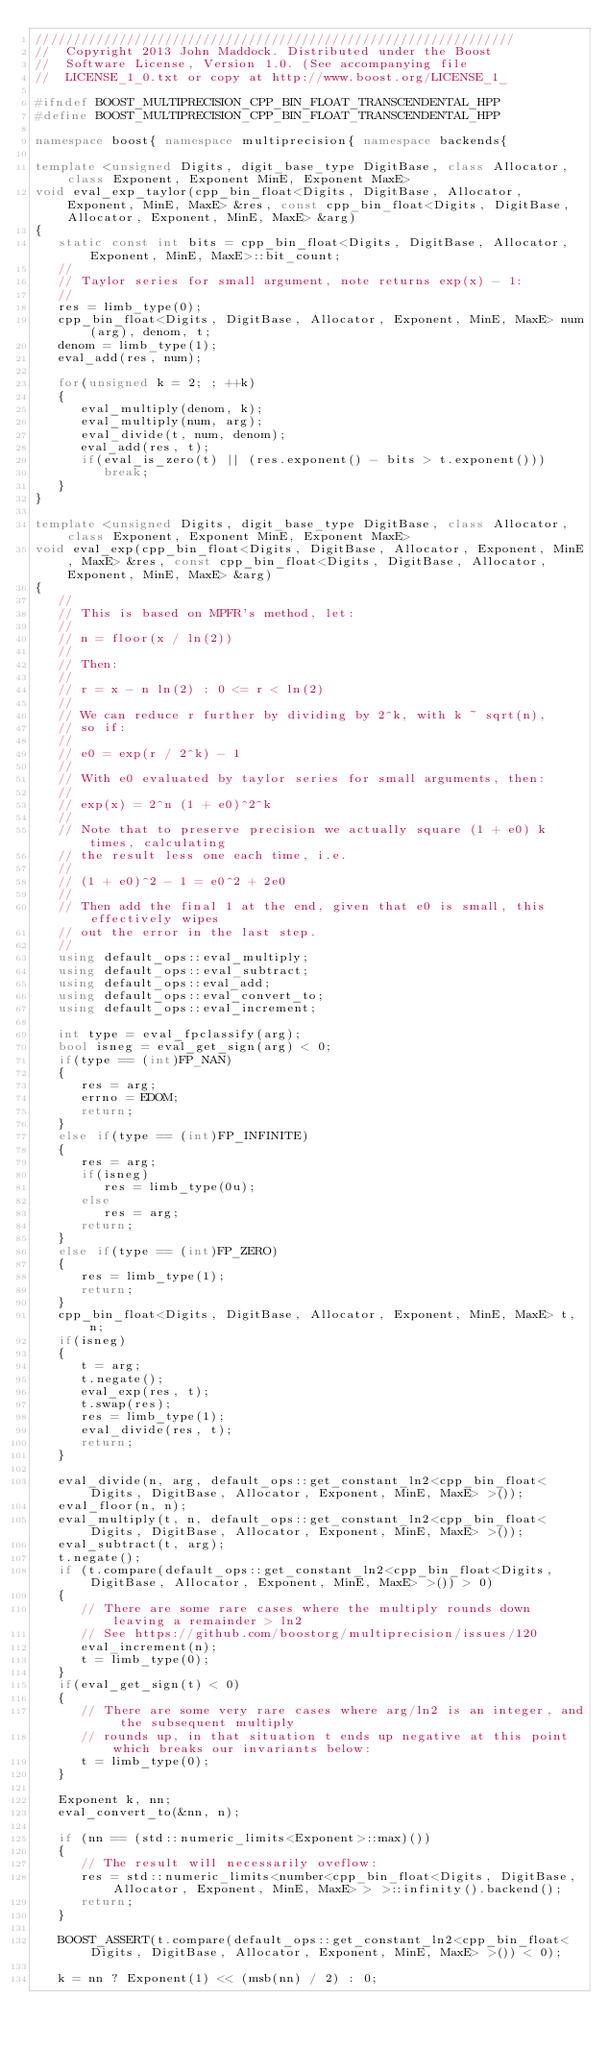<code> <loc_0><loc_0><loc_500><loc_500><_C++_>///////////////////////////////////////////////////////////////
//  Copyright 2013 John Maddock. Distributed under the Boost
//  Software License, Version 1.0. (See accompanying file
//  LICENSE_1_0.txt or copy at http://www.boost.org/LICENSE_1_

#ifndef BOOST_MULTIPRECISION_CPP_BIN_FLOAT_TRANSCENDENTAL_HPP
#define BOOST_MULTIPRECISION_CPP_BIN_FLOAT_TRANSCENDENTAL_HPP

namespace boost{ namespace multiprecision{ namespace backends{

template <unsigned Digits, digit_base_type DigitBase, class Allocator, class Exponent, Exponent MinE, Exponent MaxE>
void eval_exp_taylor(cpp_bin_float<Digits, DigitBase, Allocator, Exponent, MinE, MaxE> &res, const cpp_bin_float<Digits, DigitBase, Allocator, Exponent, MinE, MaxE> &arg)
{
   static const int bits = cpp_bin_float<Digits, DigitBase, Allocator, Exponent, MinE, MaxE>::bit_count;
   //
   // Taylor series for small argument, note returns exp(x) - 1:
   //
   res = limb_type(0);
   cpp_bin_float<Digits, DigitBase, Allocator, Exponent, MinE, MaxE> num(arg), denom, t;
   denom = limb_type(1);
   eval_add(res, num);

   for(unsigned k = 2; ; ++k)
   {
      eval_multiply(denom, k);
      eval_multiply(num, arg);
      eval_divide(t, num, denom);
      eval_add(res, t);
      if(eval_is_zero(t) || (res.exponent() - bits > t.exponent()))
         break;
   }
}

template <unsigned Digits, digit_base_type DigitBase, class Allocator, class Exponent, Exponent MinE, Exponent MaxE>
void eval_exp(cpp_bin_float<Digits, DigitBase, Allocator, Exponent, MinE, MaxE> &res, const cpp_bin_float<Digits, DigitBase, Allocator, Exponent, MinE, MaxE> &arg)
{
   //
   // This is based on MPFR's method, let:
   //
   // n = floor(x / ln(2))
   //
   // Then:
   //
   // r = x - n ln(2) : 0 <= r < ln(2)
   //
   // We can reduce r further by dividing by 2^k, with k ~ sqrt(n),
   // so if:
   //
   // e0 = exp(r / 2^k) - 1
   //
   // With e0 evaluated by taylor series for small arguments, then:
   //
   // exp(x) = 2^n (1 + e0)^2^k
   //
   // Note that to preserve precision we actually square (1 + e0) k times, calculating
   // the result less one each time, i.e.
   //
   // (1 + e0)^2 - 1 = e0^2 + 2e0
   //
   // Then add the final 1 at the end, given that e0 is small, this effectively wipes
   // out the error in the last step.
   //
   using default_ops::eval_multiply;
   using default_ops::eval_subtract;
   using default_ops::eval_add;
   using default_ops::eval_convert_to;
   using default_ops::eval_increment;

   int type = eval_fpclassify(arg);
   bool isneg = eval_get_sign(arg) < 0;
   if(type == (int)FP_NAN)
   {
      res = arg;
      errno = EDOM;
      return;
   }
   else if(type == (int)FP_INFINITE)
   {
      res = arg;
      if(isneg)
         res = limb_type(0u);
      else 
         res = arg;
      return;
   }
   else if(type == (int)FP_ZERO)
   {
      res = limb_type(1);
      return;
   }
   cpp_bin_float<Digits, DigitBase, Allocator, Exponent, MinE, MaxE> t, n;
   if(isneg)
   {
      t = arg;
      t.negate();
      eval_exp(res, t);
      t.swap(res);
      res = limb_type(1);
      eval_divide(res, t);
      return;
   }

   eval_divide(n, arg, default_ops::get_constant_ln2<cpp_bin_float<Digits, DigitBase, Allocator, Exponent, MinE, MaxE> >());
   eval_floor(n, n);
   eval_multiply(t, n, default_ops::get_constant_ln2<cpp_bin_float<Digits, DigitBase, Allocator, Exponent, MinE, MaxE> >());
   eval_subtract(t, arg);
   t.negate();
   if (t.compare(default_ops::get_constant_ln2<cpp_bin_float<Digits, DigitBase, Allocator, Exponent, MinE, MaxE> >()) > 0)
   {
      // There are some rare cases where the multiply rounds down leaving a remainder > ln2
      // See https://github.com/boostorg/multiprecision/issues/120
      eval_increment(n);
      t = limb_type(0);
   }
   if(eval_get_sign(t) < 0)
   {
      // There are some very rare cases where arg/ln2 is an integer, and the subsequent multiply
      // rounds up, in that situation t ends up negative at this point which breaks our invariants below:
      t = limb_type(0);
   }

   Exponent k, nn;
   eval_convert_to(&nn, n);

   if (nn == (std::numeric_limits<Exponent>::max)())
   {
      // The result will necessarily oveflow:
      res = std::numeric_limits<number<cpp_bin_float<Digits, DigitBase, Allocator, Exponent, MinE, MaxE> > >::infinity().backend();
      return;
   }

   BOOST_ASSERT(t.compare(default_ops::get_constant_ln2<cpp_bin_float<Digits, DigitBase, Allocator, Exponent, MinE, MaxE> >()) < 0);

   k = nn ? Exponent(1) << (msb(nn) / 2) : 0;</code> 